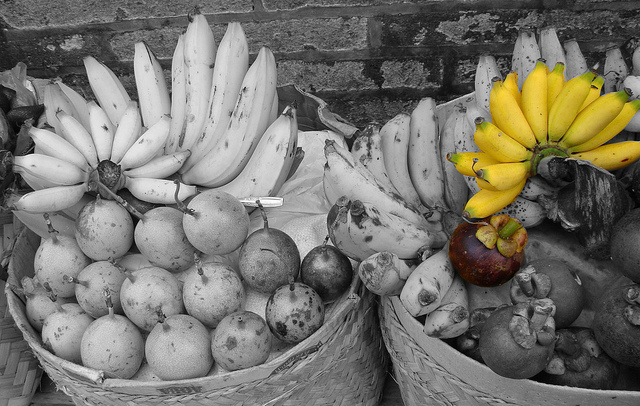Describe the content and arrangement of the two baskets shown. The image shows two baskets filled with various fruits. The left basket contains bananas and a mix of round fruits, all in grayscale. The right basket has a more vivid display with several bunches of bananas colored yellow, and a mix of other fruits including a single prominent purple fruit. 